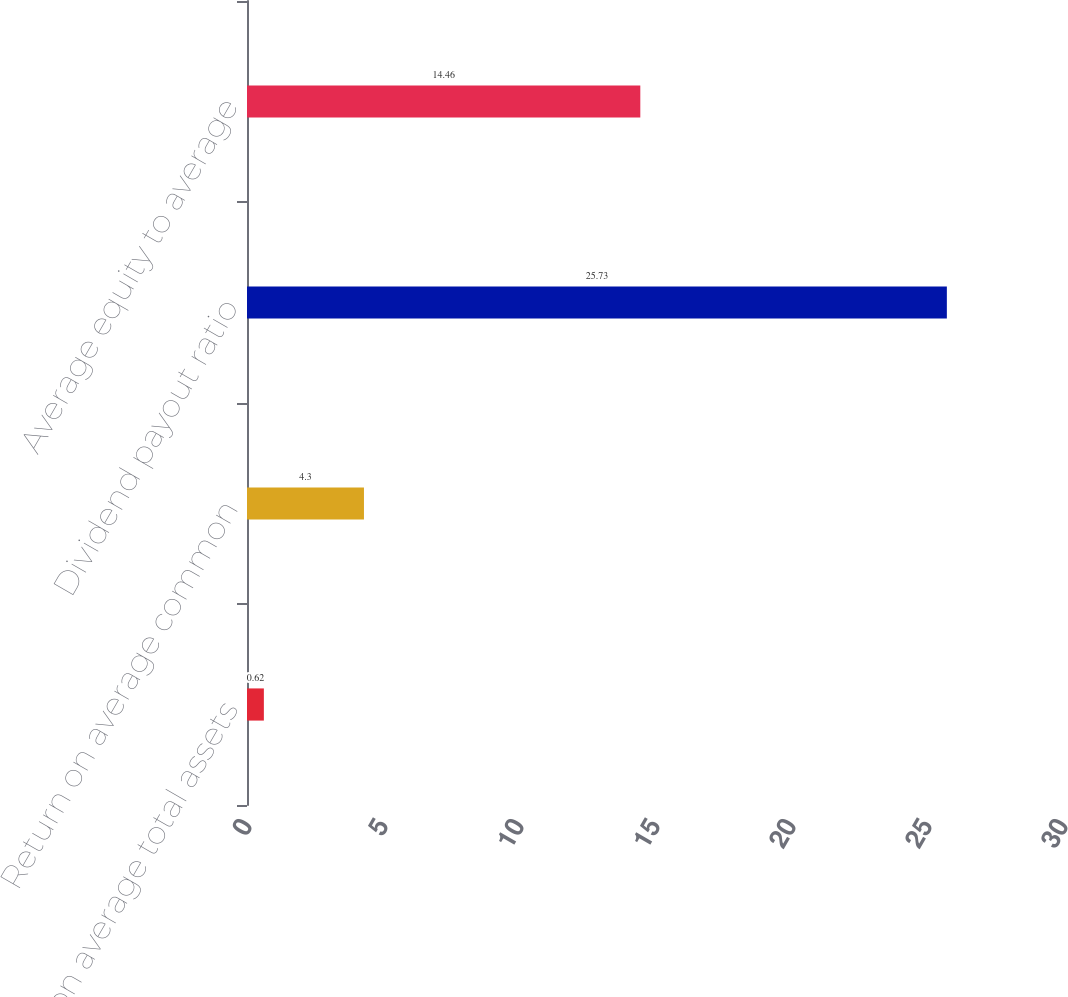Convert chart. <chart><loc_0><loc_0><loc_500><loc_500><bar_chart><fcel>Return on average total assets<fcel>Return on average common<fcel>Dividend payout ratio<fcel>Average equity to average<nl><fcel>0.62<fcel>4.3<fcel>25.73<fcel>14.46<nl></chart> 